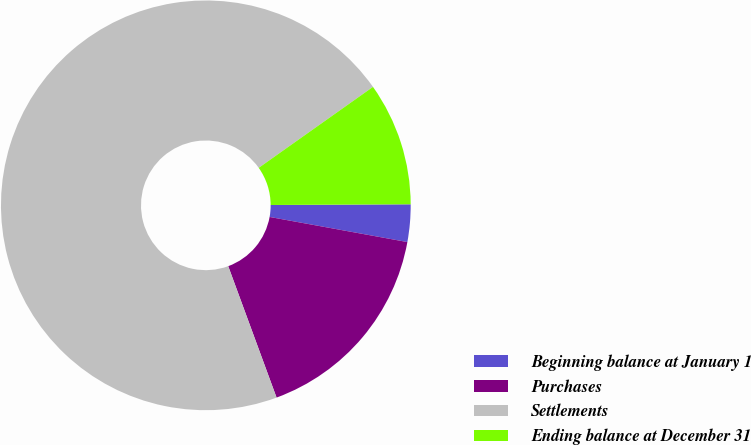<chart> <loc_0><loc_0><loc_500><loc_500><pie_chart><fcel>Beginning balance at January 1<fcel>Purchases<fcel>Settlements<fcel>Ending balance at December 31<nl><fcel>2.95%<fcel>16.52%<fcel>70.8%<fcel>9.73%<nl></chart> 